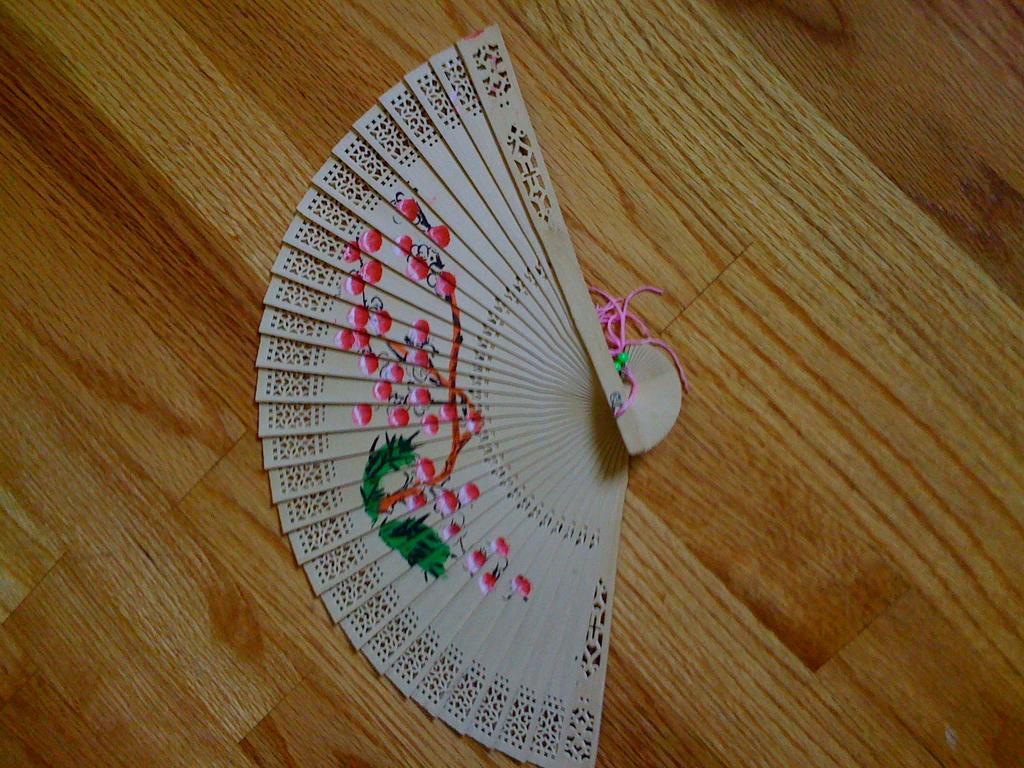How would you summarize this image in a sentence or two? In this picture we can see an object and thread on the wooden object. 